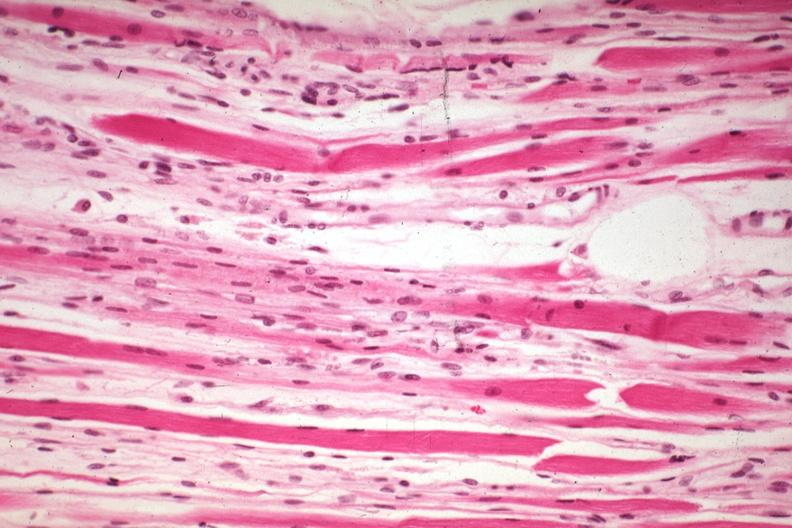s soft tissue present?
Answer the question using a single word or phrase. Yes 